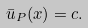<formula> <loc_0><loc_0><loc_500><loc_500>\bar { u } _ { P } ( x ) = c .</formula> 